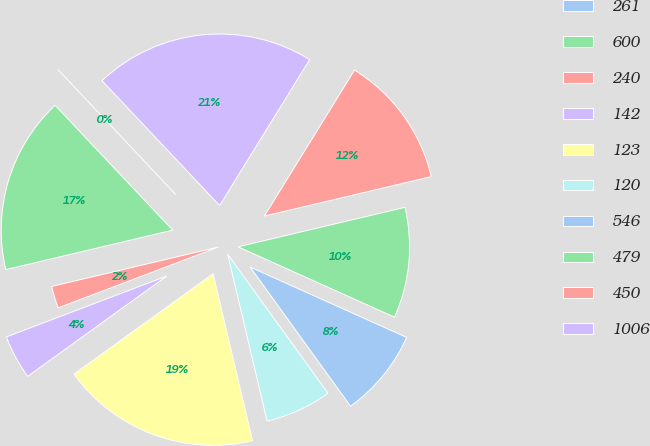Convert chart to OTSL. <chart><loc_0><loc_0><loc_500><loc_500><pie_chart><fcel>261<fcel>600<fcel>240<fcel>142<fcel>123<fcel>120<fcel>546<fcel>479<fcel>450<fcel>1006<nl><fcel>0.0%<fcel>16.67%<fcel>2.08%<fcel>4.17%<fcel>18.75%<fcel>6.25%<fcel>8.33%<fcel>10.42%<fcel>12.5%<fcel>20.83%<nl></chart> 